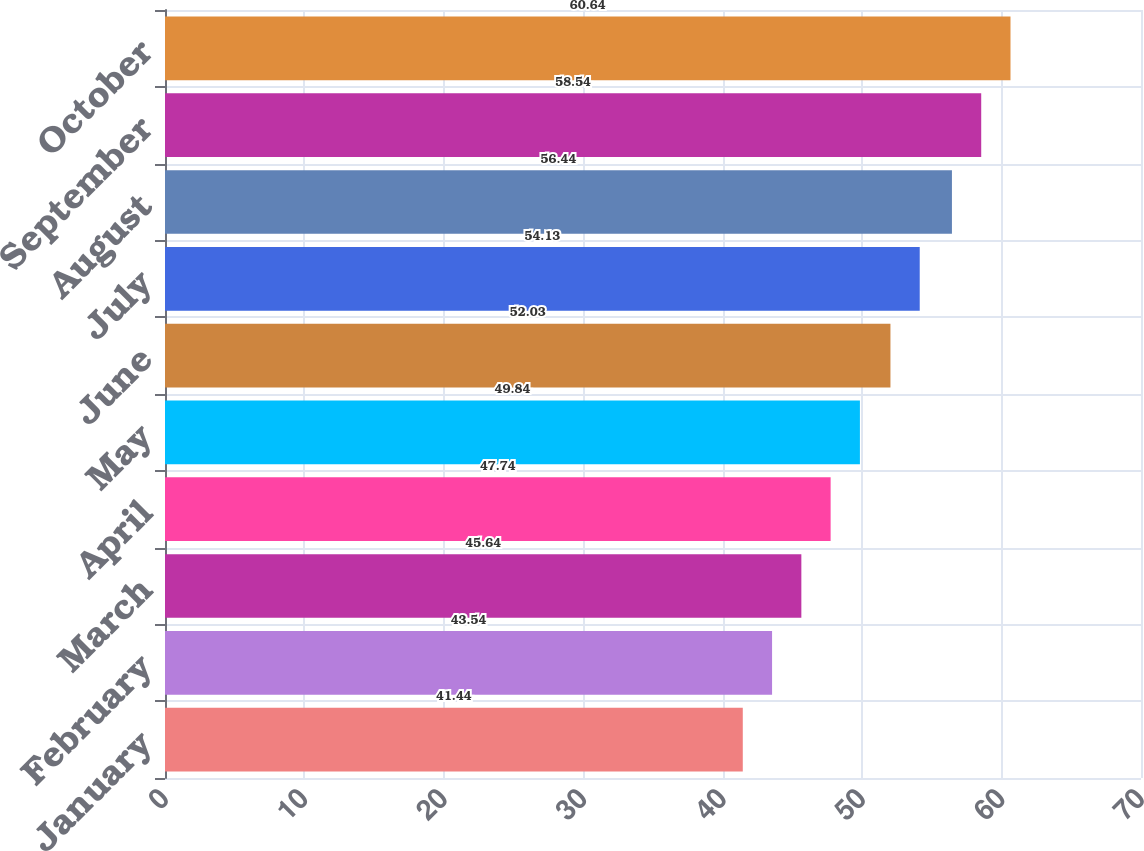Convert chart to OTSL. <chart><loc_0><loc_0><loc_500><loc_500><bar_chart><fcel>January<fcel>February<fcel>March<fcel>April<fcel>May<fcel>June<fcel>July<fcel>August<fcel>September<fcel>October<nl><fcel>41.44<fcel>43.54<fcel>45.64<fcel>47.74<fcel>49.84<fcel>52.03<fcel>54.13<fcel>56.44<fcel>58.54<fcel>60.64<nl></chart> 